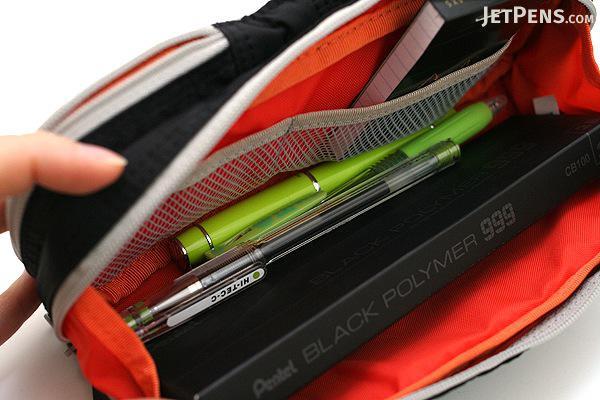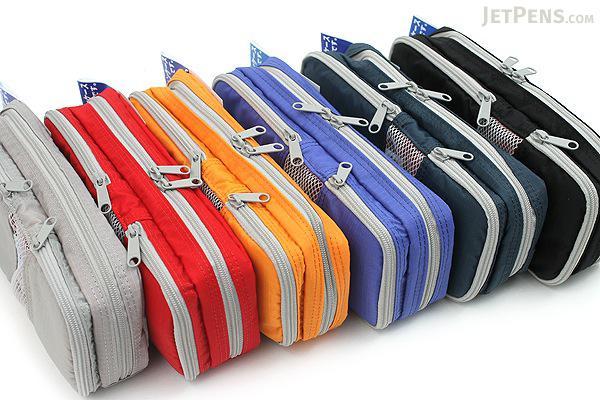The first image is the image on the left, the second image is the image on the right. Analyze the images presented: Is the assertion "A hand is opening the pencil case in at least one image." valid? Answer yes or no. Yes. The first image is the image on the left, the second image is the image on the right. For the images shown, is this caption "At least one of the images has a hand holding the pouch open." true? Answer yes or no. Yes. 